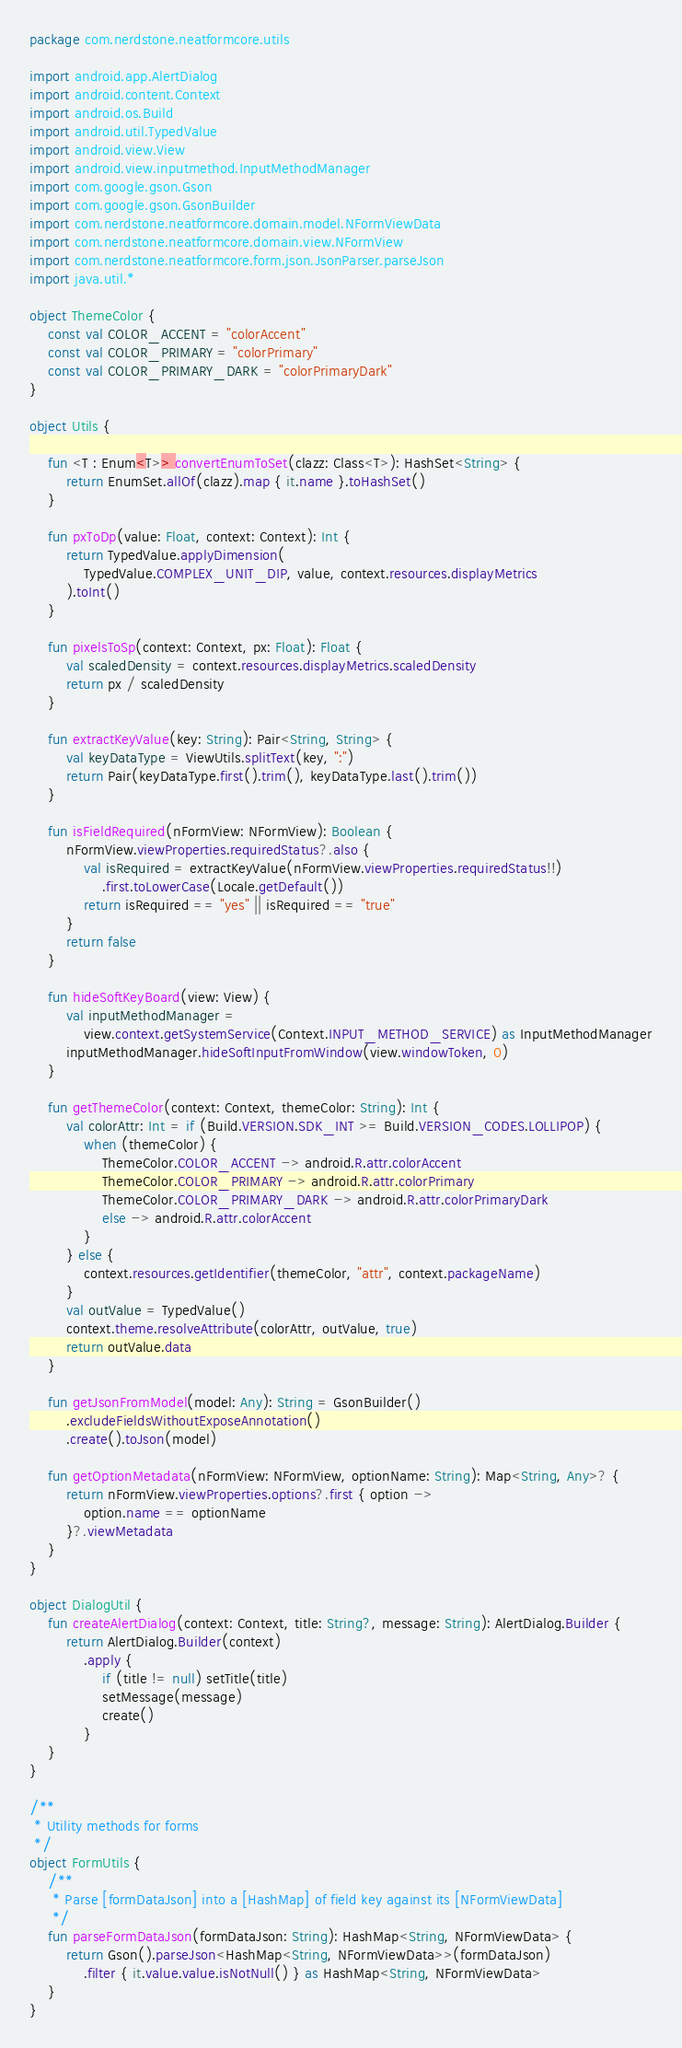Convert code to text. <code><loc_0><loc_0><loc_500><loc_500><_Kotlin_>package com.nerdstone.neatformcore.utils

import android.app.AlertDialog
import android.content.Context
import android.os.Build
import android.util.TypedValue
import android.view.View
import android.view.inputmethod.InputMethodManager
import com.google.gson.Gson
import com.google.gson.GsonBuilder
import com.nerdstone.neatformcore.domain.model.NFormViewData
import com.nerdstone.neatformcore.domain.view.NFormView
import com.nerdstone.neatformcore.form.json.JsonParser.parseJson
import java.util.*

object ThemeColor {
    const val COLOR_ACCENT = "colorAccent"
    const val COLOR_PRIMARY = "colorPrimary"
    const val COLOR_PRIMARY_DARK = "colorPrimaryDark"
}

object Utils {

    fun <T : Enum<T>> convertEnumToSet(clazz: Class<T>): HashSet<String> {
        return EnumSet.allOf(clazz).map { it.name }.toHashSet()
    }

    fun pxToDp(value: Float, context: Context): Int {
        return TypedValue.applyDimension(
            TypedValue.COMPLEX_UNIT_DIP, value, context.resources.displayMetrics
        ).toInt()
    }

    fun pixelsToSp(context: Context, px: Float): Float {
        val scaledDensity = context.resources.displayMetrics.scaledDensity
        return px / scaledDensity
    }

    fun extractKeyValue(key: String): Pair<String, String> {
        val keyDataType = ViewUtils.splitText(key, ":")
        return Pair(keyDataType.first().trim(), keyDataType.last().trim())
    }

    fun isFieldRequired(nFormView: NFormView): Boolean {
        nFormView.viewProperties.requiredStatus?.also {
            val isRequired = extractKeyValue(nFormView.viewProperties.requiredStatus!!)
                .first.toLowerCase(Locale.getDefault())
            return isRequired == "yes" || isRequired == "true"
        }
        return false
    }

    fun hideSoftKeyBoard(view: View) {
        val inputMethodManager =
            view.context.getSystemService(Context.INPUT_METHOD_SERVICE) as InputMethodManager
        inputMethodManager.hideSoftInputFromWindow(view.windowToken, 0)
    }

    fun getThemeColor(context: Context, themeColor: String): Int {
        val colorAttr: Int = if (Build.VERSION.SDK_INT >= Build.VERSION_CODES.LOLLIPOP) {
            when (themeColor) {
                ThemeColor.COLOR_ACCENT -> android.R.attr.colorAccent
                ThemeColor.COLOR_PRIMARY -> android.R.attr.colorPrimary
                ThemeColor.COLOR_PRIMARY_DARK -> android.R.attr.colorPrimaryDark
                else -> android.R.attr.colorAccent
            }
        } else {
            context.resources.getIdentifier(themeColor, "attr", context.packageName)
        }
        val outValue = TypedValue()
        context.theme.resolveAttribute(colorAttr, outValue, true)
        return outValue.data
    }

    fun getJsonFromModel(model: Any): String = GsonBuilder()
        .excludeFieldsWithoutExposeAnnotation()
        .create().toJson(model)

    fun getOptionMetadata(nFormView: NFormView, optionName: String): Map<String, Any>? {
        return nFormView.viewProperties.options?.first { option ->
            option.name == optionName
        }?.viewMetadata
    }
}

object DialogUtil {
    fun createAlertDialog(context: Context, title: String?, message: String): AlertDialog.Builder {
        return AlertDialog.Builder(context)
            .apply {
                if (title != null) setTitle(title)
                setMessage(message)
                create()
            }
    }
}

/**
 * Utility methods for forms
 */
object FormUtils {
    /**
     * Parse [formDataJson] into a [HashMap] of field key against its [NFormViewData]
     */
    fun parseFormDataJson(formDataJson: String): HashMap<String, NFormViewData> {
        return Gson().parseJson<HashMap<String, NFormViewData>>(formDataJson)
            .filter { it.value.value.isNotNull() } as HashMap<String, NFormViewData>
    }
}</code> 